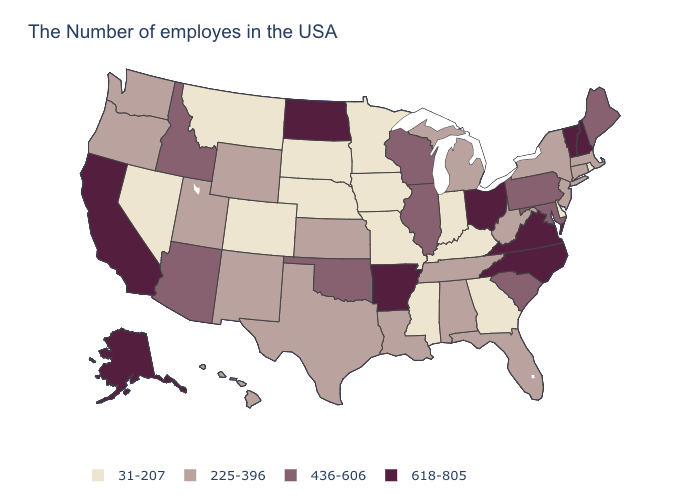Name the states that have a value in the range 618-805?
Keep it brief. New Hampshire, Vermont, Virginia, North Carolina, Ohio, Arkansas, North Dakota, California, Alaska. Does Montana have the lowest value in the West?
Quick response, please. Yes. Name the states that have a value in the range 31-207?
Give a very brief answer. Rhode Island, Delaware, Georgia, Kentucky, Indiana, Mississippi, Missouri, Minnesota, Iowa, Nebraska, South Dakota, Colorado, Montana, Nevada. Name the states that have a value in the range 31-207?
Concise answer only. Rhode Island, Delaware, Georgia, Kentucky, Indiana, Mississippi, Missouri, Minnesota, Iowa, Nebraska, South Dakota, Colorado, Montana, Nevada. Which states have the highest value in the USA?
Concise answer only. New Hampshire, Vermont, Virginia, North Carolina, Ohio, Arkansas, North Dakota, California, Alaska. Does Mississippi have the lowest value in the USA?
Write a very short answer. Yes. What is the value of South Carolina?
Short answer required. 436-606. Name the states that have a value in the range 225-396?
Quick response, please. Massachusetts, Connecticut, New York, New Jersey, West Virginia, Florida, Michigan, Alabama, Tennessee, Louisiana, Kansas, Texas, Wyoming, New Mexico, Utah, Washington, Oregon, Hawaii. What is the value of Nebraska?
Give a very brief answer. 31-207. What is the lowest value in the USA?
Give a very brief answer. 31-207. Does Nevada have the lowest value in the West?
Give a very brief answer. Yes. Among the states that border Missouri , which have the lowest value?
Give a very brief answer. Kentucky, Iowa, Nebraska. What is the lowest value in the West?
Be succinct. 31-207. Name the states that have a value in the range 31-207?
Be succinct. Rhode Island, Delaware, Georgia, Kentucky, Indiana, Mississippi, Missouri, Minnesota, Iowa, Nebraska, South Dakota, Colorado, Montana, Nevada. How many symbols are there in the legend?
Keep it brief. 4. 